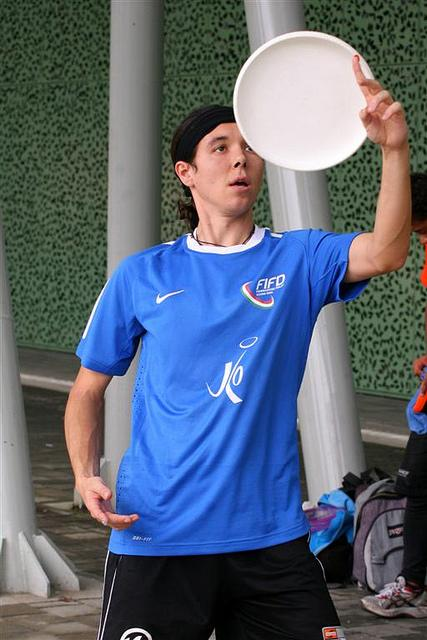What is he doing with the frisbee? Please explain your reasoning. balancing it. The man is trying to keep it upright. 